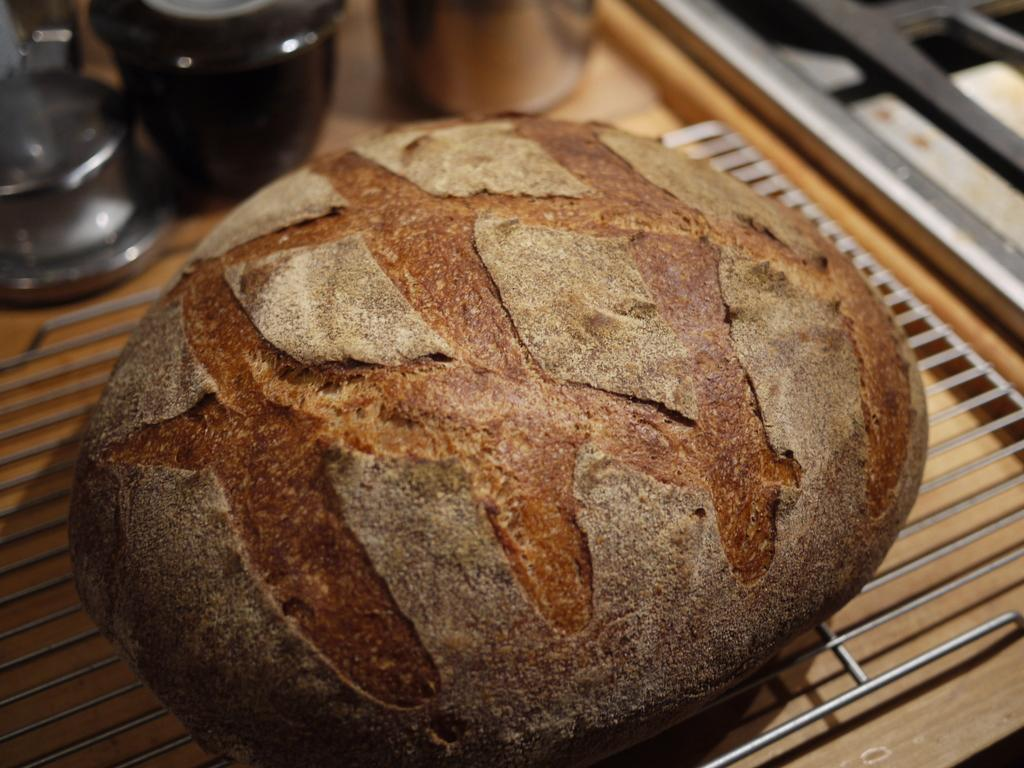What is being cooked or prepared in the image? There is a food item on grills in the image. What else can be seen in the image besides the food on the grills? There are objects on a platform in the image. Is there a woman holding a bomb on the island in the image? There is no island, woman, or bomb present in the image. The image only shows a food item on grills and objects on a platform. 